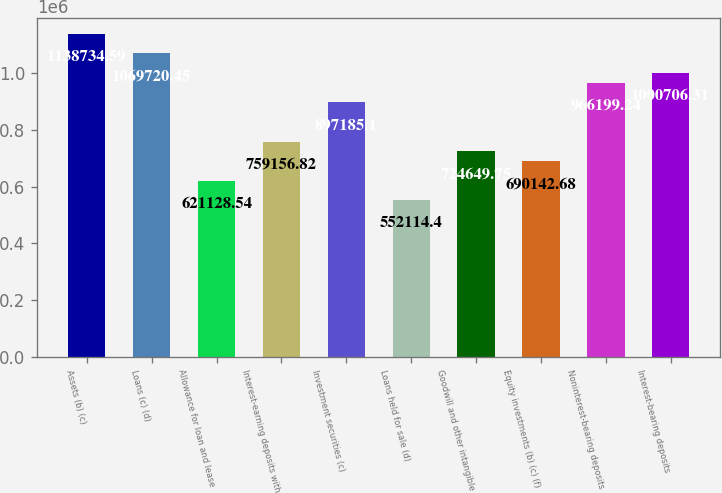Convert chart. <chart><loc_0><loc_0><loc_500><loc_500><bar_chart><fcel>Assets (b) (c)<fcel>Loans (c) (d)<fcel>Allowance for loan and lease<fcel>Interest-earning deposits with<fcel>Investment securities (c)<fcel>Loans held for sale (d)<fcel>Goodwill and other intangible<fcel>Equity investments (b) (c) (f)<fcel>Noninterest-bearing deposits<fcel>Interest-bearing deposits<nl><fcel>1.13873e+06<fcel>1.06972e+06<fcel>621129<fcel>759157<fcel>897185<fcel>552114<fcel>724650<fcel>690143<fcel>966199<fcel>1.00071e+06<nl></chart> 